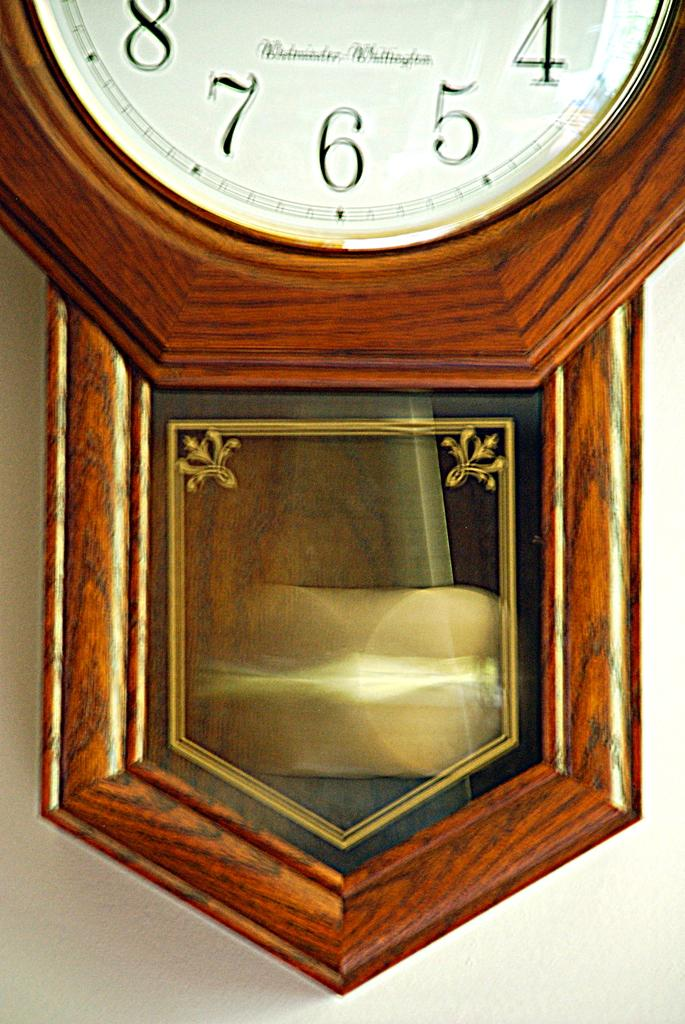<image>
Give a short and clear explanation of the subsequent image. A close up of a clock that shows the numbers 4, 5, 6, 7, and 8. 